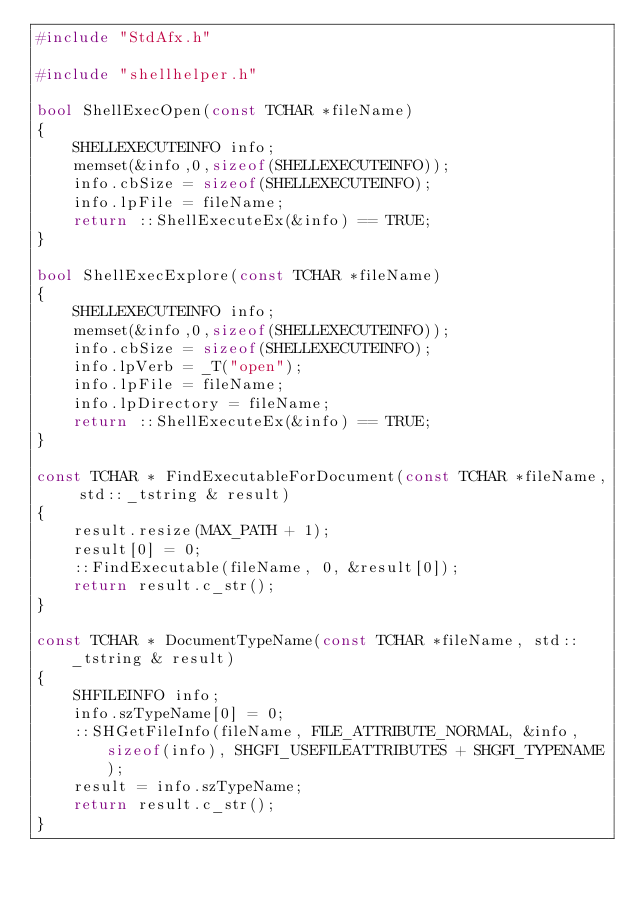<code> <loc_0><loc_0><loc_500><loc_500><_C++_>#include "StdAfx.h"

#include "shellhelper.h"

bool ShellExecOpen(const TCHAR *fileName)
{
    SHELLEXECUTEINFO info;
    memset(&info,0,sizeof(SHELLEXECUTEINFO));
    info.cbSize = sizeof(SHELLEXECUTEINFO);
    info.lpFile = fileName;
    return ::ShellExecuteEx(&info) == TRUE;
}

bool ShellExecExplore(const TCHAR *fileName)
{
    SHELLEXECUTEINFO info;
    memset(&info,0,sizeof(SHELLEXECUTEINFO));
    info.cbSize = sizeof(SHELLEXECUTEINFO);
    info.lpVerb = _T("open");
    info.lpFile = fileName;
    info.lpDirectory = fileName;
    return ::ShellExecuteEx(&info) == TRUE;
}

const TCHAR * FindExecutableForDocument(const TCHAR *fileName, std::_tstring & result)
{
    result.resize(MAX_PATH + 1);
    result[0] = 0;
    ::FindExecutable(fileName, 0, &result[0]);
    return result.c_str();
}

const TCHAR * DocumentTypeName(const TCHAR *fileName, std::_tstring & result)
{
    SHFILEINFO info;
    info.szTypeName[0] = 0;
    ::SHGetFileInfo(fileName, FILE_ATTRIBUTE_NORMAL, &info, sizeof(info), SHGFI_USEFILEATTRIBUTES + SHGFI_TYPENAME);
    result = info.szTypeName;
    return result.c_str();
}</code> 